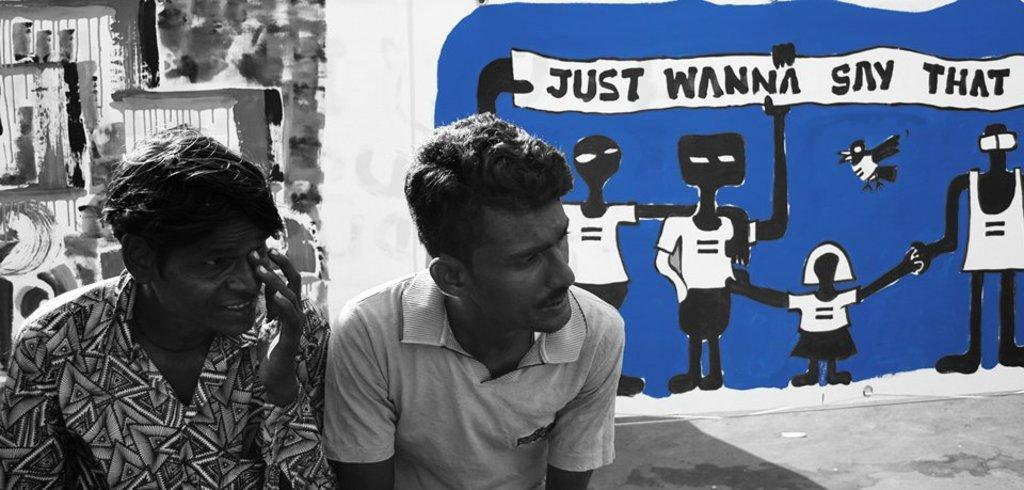How many people are present in the image? There are two men in the image. What can be seen in the background of the image? There are drawings in the background of the image. Is there any text visible in the image? Yes, there is writing visible in the image. What type of stem can be seen growing from the downtown area in the image? There is no downtown area or stem present in the image. 